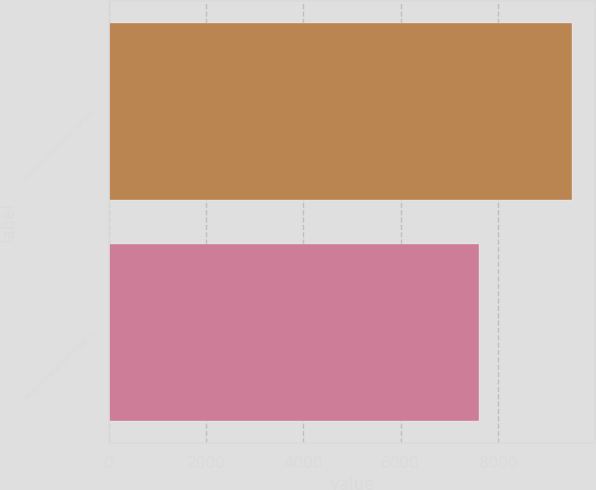<chart> <loc_0><loc_0><loc_500><loc_500><bar_chart><fcel>Variable transaction fee per<fcel>Total increase (decrease) in<nl><fcel>9523<fcel>7608<nl></chart> 